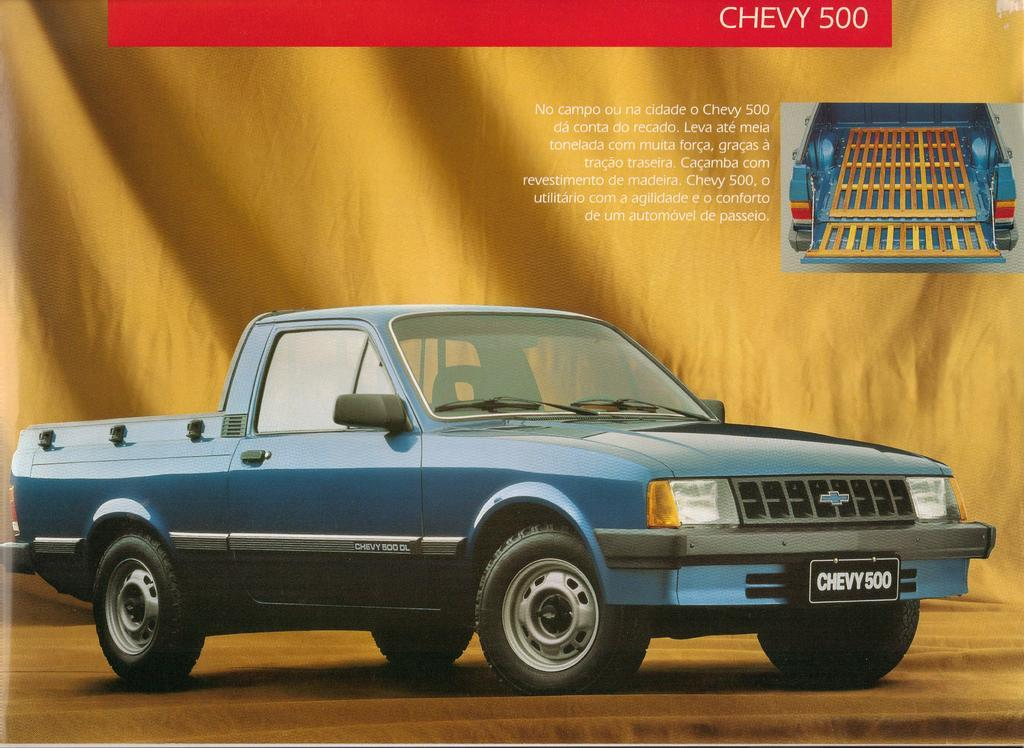What type of visual is the image? The image is a poster. What is the main subject of the poster? There is a car in the image. What else can be seen in the background of the poster? There is text and a picture in the background of the image. What line is being crossed in the image? There is no line present in the image to be crossed. 